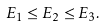<formula> <loc_0><loc_0><loc_500><loc_500>E _ { 1 } \leq E _ { 2 } \leq E _ { 3 } .</formula> 